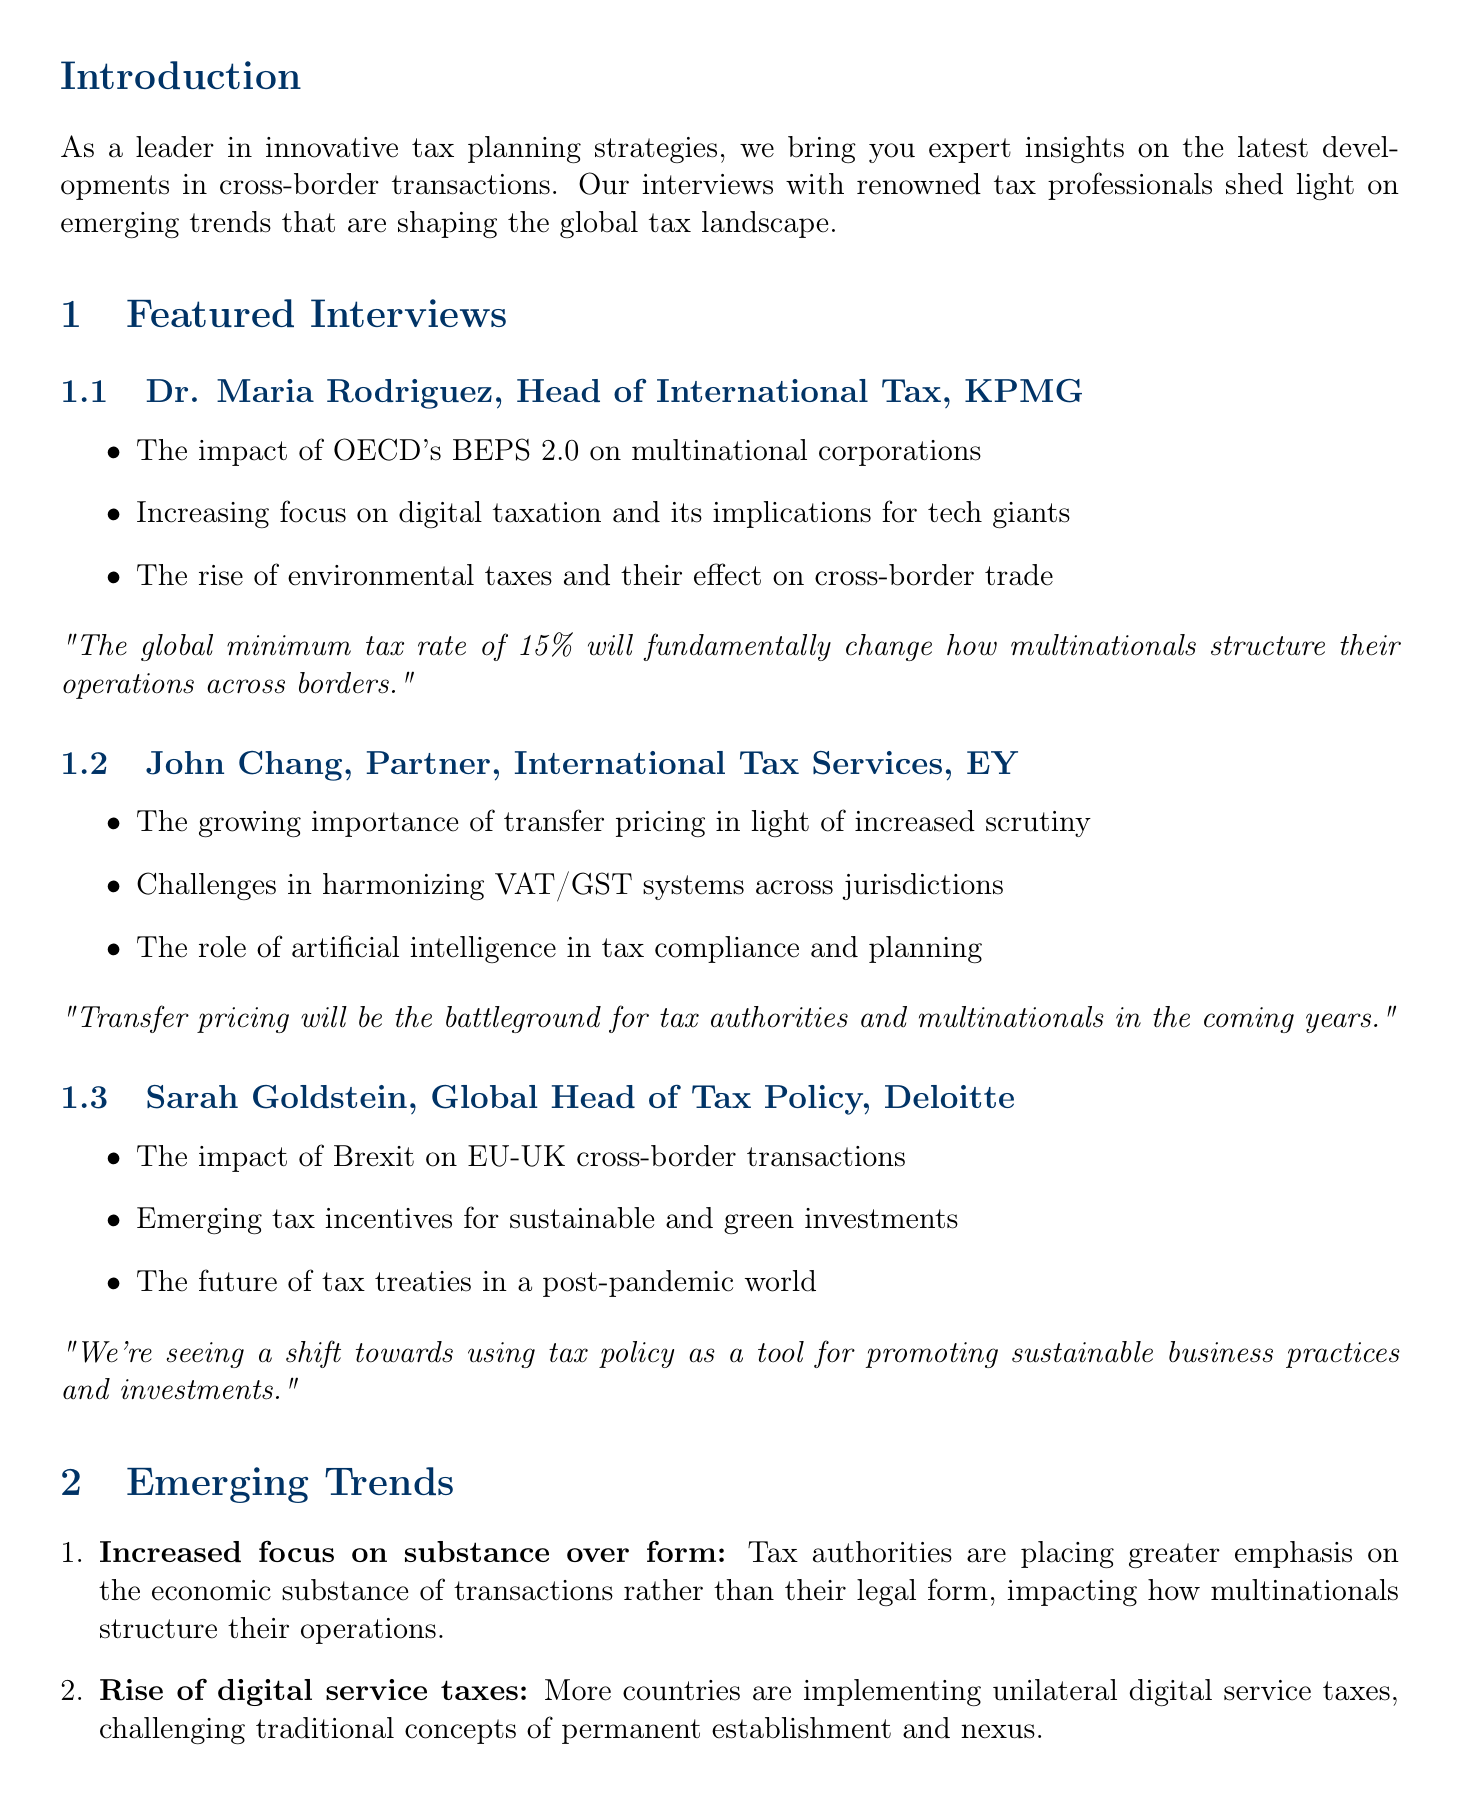what is the title of the newsletter? The title of the newsletter is stated at the beginning of the document, which is "Global Tax Insights: Emerging Trends in Cross-Border Transactions."
Answer: Global Tax Insights: Emerging Trends in Cross-Border Transactions who is the expert from KPMG? The document mentions Dr. Maria Rodriguez as the expert from KPMG.
Answer: Dr. Maria Rodriguez what trend discusses the implementation of unilateral digital service taxes? The trend related to unilateral digital service taxes is labeled as "Rise of digital service taxes."
Answer: Rise of digital service taxes how many key points did John Chang highlight? John Chang highlighted three key points during his interview.
Answer: 3 what is the key challenge faced by TechGlobal Inc.? The document explicitly states the challenge faced by TechGlobal Inc. as the navigation of digital service taxes across multiple jurisdictions.
Answer: Navigating the complex web of digital service taxes across multiple jurisdictions which trend emphasizes compliance burden increase? The trend that emphasizes an increase in compliance burden is described as "Enhanced transparency and reporting requirements."
Answer: Enhanced transparency and reporting requirements what is the outcome for TechGlobal Inc. after implementing their solution? The outcome is detailed in the case study, indicating that they achieved full compliance while optimizing tax efficiency, resulting in millions of dollars in tax savings.
Answer: Achieved full compliance while optimizing tax efficiency, resulting in millions of dollars in tax savings who is the global head of tax policy at Deloitte? Sarah Goldstein is identified as the Global Head of Tax Policy at Deloitte in the document.
Answer: Sarah Goldstein 